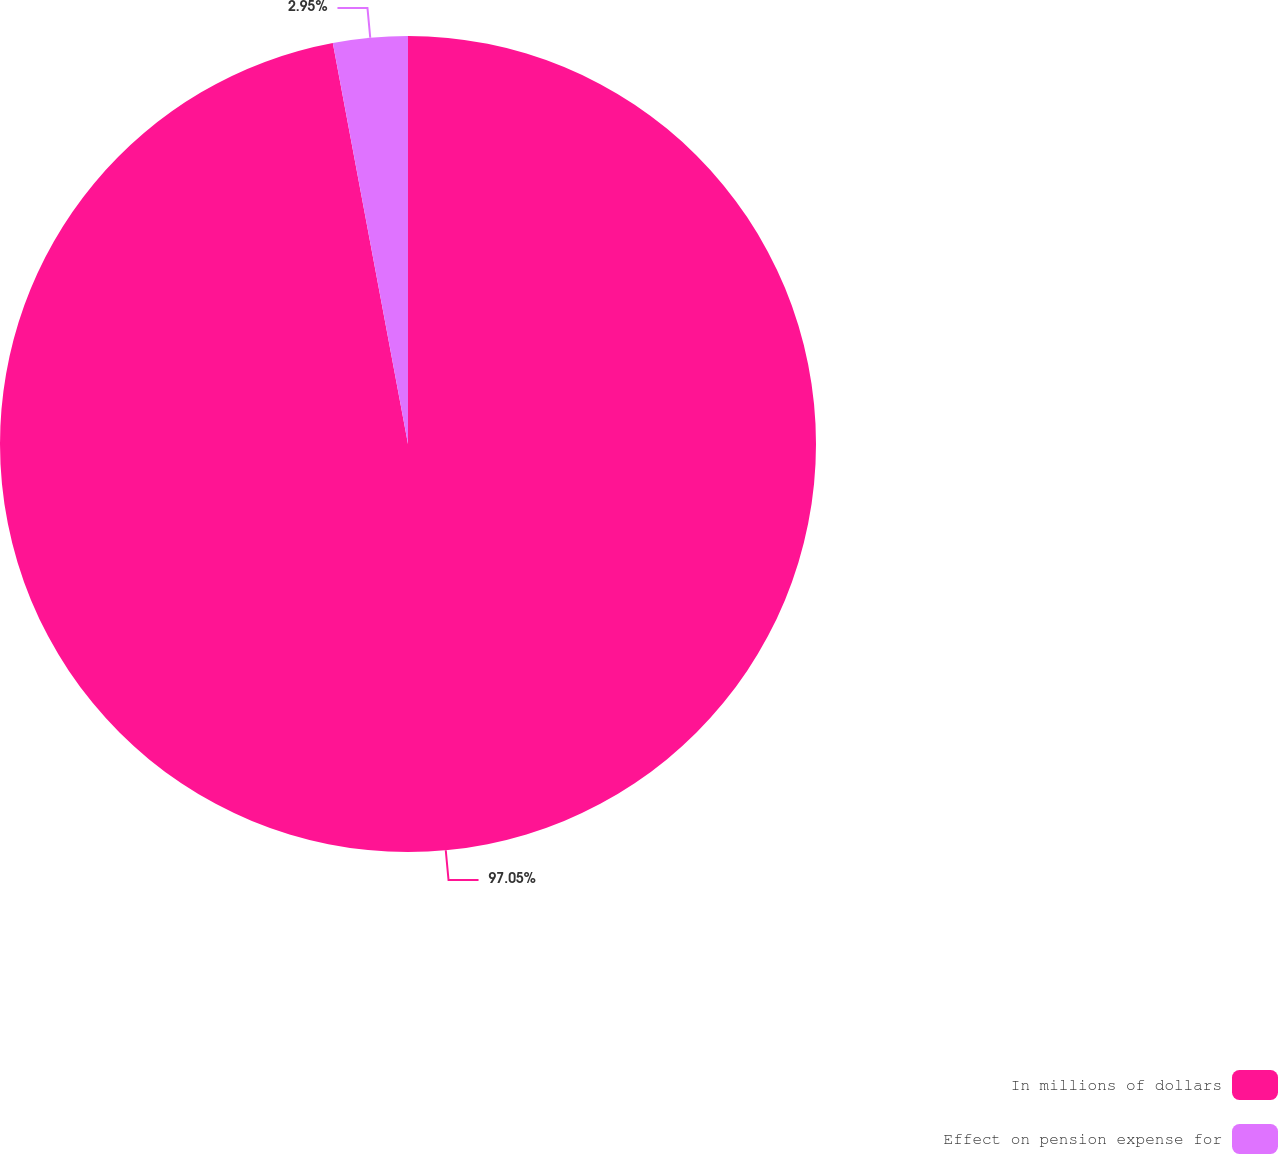<chart> <loc_0><loc_0><loc_500><loc_500><pie_chart><fcel>In millions of dollars<fcel>Effect on pension expense for<nl><fcel>97.05%<fcel>2.95%<nl></chart> 